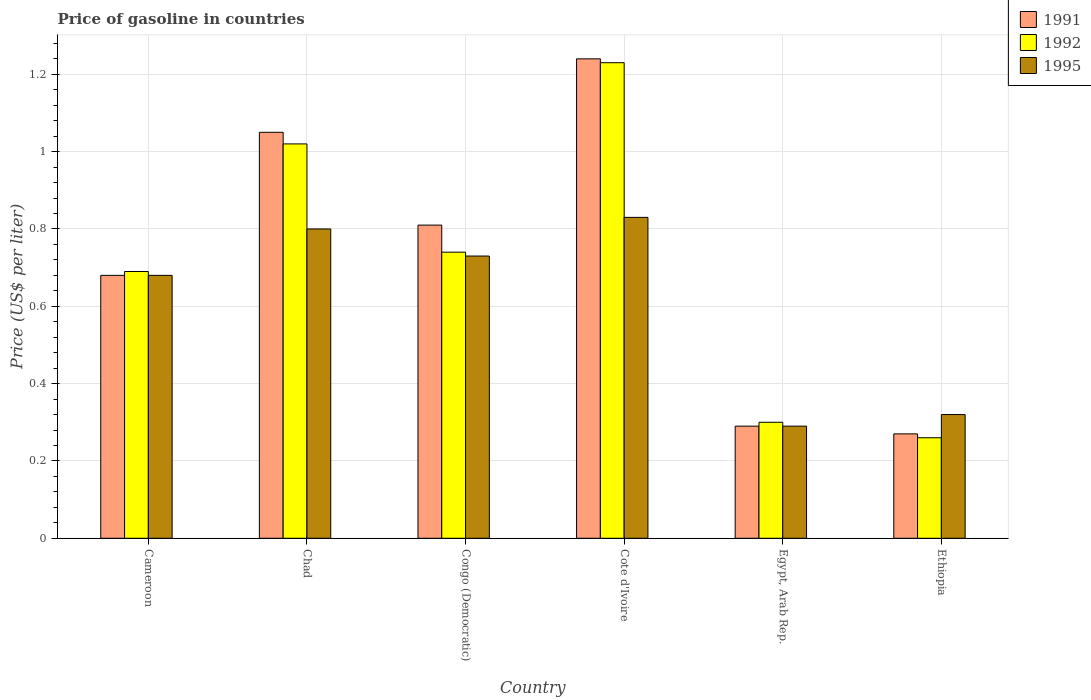How many groups of bars are there?
Offer a terse response. 6. Are the number of bars per tick equal to the number of legend labels?
Ensure brevity in your answer.  Yes. Are the number of bars on each tick of the X-axis equal?
Provide a succinct answer. Yes. What is the label of the 4th group of bars from the left?
Your answer should be compact. Cote d'Ivoire. What is the price of gasoline in 1995 in Cote d'Ivoire?
Provide a short and direct response. 0.83. Across all countries, what is the maximum price of gasoline in 1992?
Offer a terse response. 1.23. Across all countries, what is the minimum price of gasoline in 1992?
Provide a short and direct response. 0.26. In which country was the price of gasoline in 1991 maximum?
Offer a very short reply. Cote d'Ivoire. In which country was the price of gasoline in 1991 minimum?
Keep it short and to the point. Ethiopia. What is the total price of gasoline in 1992 in the graph?
Offer a terse response. 4.24. What is the difference between the price of gasoline in 1992 in Congo (Democratic) and that in Ethiopia?
Provide a short and direct response. 0.48. What is the difference between the price of gasoline in 1995 in Congo (Democratic) and the price of gasoline in 1992 in Ethiopia?
Give a very brief answer. 0.47. What is the average price of gasoline in 1991 per country?
Your answer should be compact. 0.72. What is the difference between the price of gasoline of/in 1995 and price of gasoline of/in 1991 in Cote d'Ivoire?
Your answer should be compact. -0.41. In how many countries, is the price of gasoline in 1995 greater than 0.9600000000000001 US$?
Offer a very short reply. 0. What is the ratio of the price of gasoline in 1992 in Chad to that in Cote d'Ivoire?
Offer a very short reply. 0.83. Is the difference between the price of gasoline in 1995 in Cameroon and Congo (Democratic) greater than the difference between the price of gasoline in 1991 in Cameroon and Congo (Democratic)?
Give a very brief answer. Yes. What is the difference between the highest and the second highest price of gasoline in 1991?
Make the answer very short. -0.43. What is the difference between the highest and the lowest price of gasoline in 1991?
Your answer should be very brief. 0.97. What does the 2nd bar from the left in Ethiopia represents?
Make the answer very short. 1992. What does the 2nd bar from the right in Chad represents?
Offer a terse response. 1992. Does the graph contain grids?
Ensure brevity in your answer.  Yes. Where does the legend appear in the graph?
Give a very brief answer. Top right. What is the title of the graph?
Your answer should be very brief. Price of gasoline in countries. Does "1996" appear as one of the legend labels in the graph?
Your response must be concise. No. What is the label or title of the Y-axis?
Keep it short and to the point. Price (US$ per liter). What is the Price (US$ per liter) of 1991 in Cameroon?
Keep it short and to the point. 0.68. What is the Price (US$ per liter) in 1992 in Cameroon?
Provide a succinct answer. 0.69. What is the Price (US$ per liter) of 1995 in Cameroon?
Provide a short and direct response. 0.68. What is the Price (US$ per liter) of 1991 in Chad?
Ensure brevity in your answer.  1.05. What is the Price (US$ per liter) of 1995 in Chad?
Provide a succinct answer. 0.8. What is the Price (US$ per liter) in 1991 in Congo (Democratic)?
Offer a terse response. 0.81. What is the Price (US$ per liter) in 1992 in Congo (Democratic)?
Ensure brevity in your answer.  0.74. What is the Price (US$ per liter) in 1995 in Congo (Democratic)?
Give a very brief answer. 0.73. What is the Price (US$ per liter) of 1991 in Cote d'Ivoire?
Give a very brief answer. 1.24. What is the Price (US$ per liter) of 1992 in Cote d'Ivoire?
Offer a very short reply. 1.23. What is the Price (US$ per liter) of 1995 in Cote d'Ivoire?
Keep it short and to the point. 0.83. What is the Price (US$ per liter) of 1991 in Egypt, Arab Rep.?
Give a very brief answer. 0.29. What is the Price (US$ per liter) in 1992 in Egypt, Arab Rep.?
Your response must be concise. 0.3. What is the Price (US$ per liter) of 1995 in Egypt, Arab Rep.?
Give a very brief answer. 0.29. What is the Price (US$ per liter) of 1991 in Ethiopia?
Provide a short and direct response. 0.27. What is the Price (US$ per liter) in 1992 in Ethiopia?
Your answer should be compact. 0.26. What is the Price (US$ per liter) in 1995 in Ethiopia?
Ensure brevity in your answer.  0.32. Across all countries, what is the maximum Price (US$ per liter) of 1991?
Keep it short and to the point. 1.24. Across all countries, what is the maximum Price (US$ per liter) of 1992?
Your response must be concise. 1.23. Across all countries, what is the maximum Price (US$ per liter) in 1995?
Ensure brevity in your answer.  0.83. Across all countries, what is the minimum Price (US$ per liter) in 1991?
Your answer should be very brief. 0.27. Across all countries, what is the minimum Price (US$ per liter) of 1992?
Keep it short and to the point. 0.26. Across all countries, what is the minimum Price (US$ per liter) in 1995?
Make the answer very short. 0.29. What is the total Price (US$ per liter) in 1991 in the graph?
Keep it short and to the point. 4.34. What is the total Price (US$ per liter) in 1992 in the graph?
Keep it short and to the point. 4.24. What is the total Price (US$ per liter) of 1995 in the graph?
Make the answer very short. 3.65. What is the difference between the Price (US$ per liter) of 1991 in Cameroon and that in Chad?
Keep it short and to the point. -0.37. What is the difference between the Price (US$ per liter) in 1992 in Cameroon and that in Chad?
Your answer should be very brief. -0.33. What is the difference between the Price (US$ per liter) of 1995 in Cameroon and that in Chad?
Give a very brief answer. -0.12. What is the difference between the Price (US$ per liter) in 1991 in Cameroon and that in Congo (Democratic)?
Offer a very short reply. -0.13. What is the difference between the Price (US$ per liter) in 1992 in Cameroon and that in Congo (Democratic)?
Your answer should be compact. -0.05. What is the difference between the Price (US$ per liter) of 1995 in Cameroon and that in Congo (Democratic)?
Give a very brief answer. -0.05. What is the difference between the Price (US$ per liter) in 1991 in Cameroon and that in Cote d'Ivoire?
Offer a very short reply. -0.56. What is the difference between the Price (US$ per liter) of 1992 in Cameroon and that in Cote d'Ivoire?
Provide a succinct answer. -0.54. What is the difference between the Price (US$ per liter) of 1995 in Cameroon and that in Cote d'Ivoire?
Provide a short and direct response. -0.15. What is the difference between the Price (US$ per liter) in 1991 in Cameroon and that in Egypt, Arab Rep.?
Offer a terse response. 0.39. What is the difference between the Price (US$ per liter) of 1992 in Cameroon and that in Egypt, Arab Rep.?
Ensure brevity in your answer.  0.39. What is the difference between the Price (US$ per liter) in 1995 in Cameroon and that in Egypt, Arab Rep.?
Provide a succinct answer. 0.39. What is the difference between the Price (US$ per liter) of 1991 in Cameroon and that in Ethiopia?
Your answer should be very brief. 0.41. What is the difference between the Price (US$ per liter) of 1992 in Cameroon and that in Ethiopia?
Make the answer very short. 0.43. What is the difference between the Price (US$ per liter) in 1995 in Cameroon and that in Ethiopia?
Your answer should be very brief. 0.36. What is the difference between the Price (US$ per liter) of 1991 in Chad and that in Congo (Democratic)?
Make the answer very short. 0.24. What is the difference between the Price (US$ per liter) of 1992 in Chad and that in Congo (Democratic)?
Ensure brevity in your answer.  0.28. What is the difference between the Price (US$ per liter) in 1995 in Chad and that in Congo (Democratic)?
Your response must be concise. 0.07. What is the difference between the Price (US$ per liter) in 1991 in Chad and that in Cote d'Ivoire?
Offer a very short reply. -0.19. What is the difference between the Price (US$ per liter) in 1992 in Chad and that in Cote d'Ivoire?
Your response must be concise. -0.21. What is the difference between the Price (US$ per liter) in 1995 in Chad and that in Cote d'Ivoire?
Provide a short and direct response. -0.03. What is the difference between the Price (US$ per liter) of 1991 in Chad and that in Egypt, Arab Rep.?
Offer a very short reply. 0.76. What is the difference between the Price (US$ per liter) of 1992 in Chad and that in Egypt, Arab Rep.?
Your response must be concise. 0.72. What is the difference between the Price (US$ per liter) of 1995 in Chad and that in Egypt, Arab Rep.?
Make the answer very short. 0.51. What is the difference between the Price (US$ per liter) in 1991 in Chad and that in Ethiopia?
Ensure brevity in your answer.  0.78. What is the difference between the Price (US$ per liter) in 1992 in Chad and that in Ethiopia?
Your answer should be very brief. 0.76. What is the difference between the Price (US$ per liter) of 1995 in Chad and that in Ethiopia?
Offer a terse response. 0.48. What is the difference between the Price (US$ per liter) in 1991 in Congo (Democratic) and that in Cote d'Ivoire?
Offer a very short reply. -0.43. What is the difference between the Price (US$ per liter) of 1992 in Congo (Democratic) and that in Cote d'Ivoire?
Offer a very short reply. -0.49. What is the difference between the Price (US$ per liter) in 1991 in Congo (Democratic) and that in Egypt, Arab Rep.?
Keep it short and to the point. 0.52. What is the difference between the Price (US$ per liter) of 1992 in Congo (Democratic) and that in Egypt, Arab Rep.?
Keep it short and to the point. 0.44. What is the difference between the Price (US$ per liter) in 1995 in Congo (Democratic) and that in Egypt, Arab Rep.?
Provide a succinct answer. 0.44. What is the difference between the Price (US$ per liter) in 1991 in Congo (Democratic) and that in Ethiopia?
Your response must be concise. 0.54. What is the difference between the Price (US$ per liter) of 1992 in Congo (Democratic) and that in Ethiopia?
Offer a terse response. 0.48. What is the difference between the Price (US$ per liter) of 1995 in Congo (Democratic) and that in Ethiopia?
Your answer should be very brief. 0.41. What is the difference between the Price (US$ per liter) of 1992 in Cote d'Ivoire and that in Egypt, Arab Rep.?
Your answer should be compact. 0.93. What is the difference between the Price (US$ per liter) of 1995 in Cote d'Ivoire and that in Egypt, Arab Rep.?
Offer a very short reply. 0.54. What is the difference between the Price (US$ per liter) of 1991 in Cote d'Ivoire and that in Ethiopia?
Provide a short and direct response. 0.97. What is the difference between the Price (US$ per liter) in 1995 in Cote d'Ivoire and that in Ethiopia?
Offer a very short reply. 0.51. What is the difference between the Price (US$ per liter) in 1991 in Egypt, Arab Rep. and that in Ethiopia?
Make the answer very short. 0.02. What is the difference between the Price (US$ per liter) of 1992 in Egypt, Arab Rep. and that in Ethiopia?
Your answer should be compact. 0.04. What is the difference between the Price (US$ per liter) in 1995 in Egypt, Arab Rep. and that in Ethiopia?
Ensure brevity in your answer.  -0.03. What is the difference between the Price (US$ per liter) in 1991 in Cameroon and the Price (US$ per liter) in 1992 in Chad?
Keep it short and to the point. -0.34. What is the difference between the Price (US$ per liter) of 1991 in Cameroon and the Price (US$ per liter) of 1995 in Chad?
Ensure brevity in your answer.  -0.12. What is the difference between the Price (US$ per liter) in 1992 in Cameroon and the Price (US$ per liter) in 1995 in Chad?
Provide a succinct answer. -0.11. What is the difference between the Price (US$ per liter) of 1991 in Cameroon and the Price (US$ per liter) of 1992 in Congo (Democratic)?
Offer a terse response. -0.06. What is the difference between the Price (US$ per liter) in 1991 in Cameroon and the Price (US$ per liter) in 1995 in Congo (Democratic)?
Make the answer very short. -0.05. What is the difference between the Price (US$ per liter) in 1992 in Cameroon and the Price (US$ per liter) in 1995 in Congo (Democratic)?
Keep it short and to the point. -0.04. What is the difference between the Price (US$ per liter) of 1991 in Cameroon and the Price (US$ per liter) of 1992 in Cote d'Ivoire?
Your response must be concise. -0.55. What is the difference between the Price (US$ per liter) in 1992 in Cameroon and the Price (US$ per liter) in 1995 in Cote d'Ivoire?
Your answer should be very brief. -0.14. What is the difference between the Price (US$ per liter) of 1991 in Cameroon and the Price (US$ per liter) of 1992 in Egypt, Arab Rep.?
Keep it short and to the point. 0.38. What is the difference between the Price (US$ per liter) of 1991 in Cameroon and the Price (US$ per liter) of 1995 in Egypt, Arab Rep.?
Offer a terse response. 0.39. What is the difference between the Price (US$ per liter) in 1991 in Cameroon and the Price (US$ per liter) in 1992 in Ethiopia?
Keep it short and to the point. 0.42. What is the difference between the Price (US$ per liter) in 1991 in Cameroon and the Price (US$ per liter) in 1995 in Ethiopia?
Offer a very short reply. 0.36. What is the difference between the Price (US$ per liter) in 1992 in Cameroon and the Price (US$ per liter) in 1995 in Ethiopia?
Offer a terse response. 0.37. What is the difference between the Price (US$ per liter) in 1991 in Chad and the Price (US$ per liter) in 1992 in Congo (Democratic)?
Provide a succinct answer. 0.31. What is the difference between the Price (US$ per liter) of 1991 in Chad and the Price (US$ per liter) of 1995 in Congo (Democratic)?
Offer a very short reply. 0.32. What is the difference between the Price (US$ per liter) in 1992 in Chad and the Price (US$ per liter) in 1995 in Congo (Democratic)?
Offer a very short reply. 0.29. What is the difference between the Price (US$ per liter) in 1991 in Chad and the Price (US$ per liter) in 1992 in Cote d'Ivoire?
Your answer should be compact. -0.18. What is the difference between the Price (US$ per liter) of 1991 in Chad and the Price (US$ per liter) of 1995 in Cote d'Ivoire?
Keep it short and to the point. 0.22. What is the difference between the Price (US$ per liter) in 1992 in Chad and the Price (US$ per liter) in 1995 in Cote d'Ivoire?
Offer a terse response. 0.19. What is the difference between the Price (US$ per liter) in 1991 in Chad and the Price (US$ per liter) in 1992 in Egypt, Arab Rep.?
Offer a very short reply. 0.75. What is the difference between the Price (US$ per liter) of 1991 in Chad and the Price (US$ per liter) of 1995 in Egypt, Arab Rep.?
Ensure brevity in your answer.  0.76. What is the difference between the Price (US$ per liter) in 1992 in Chad and the Price (US$ per liter) in 1995 in Egypt, Arab Rep.?
Offer a very short reply. 0.73. What is the difference between the Price (US$ per liter) of 1991 in Chad and the Price (US$ per liter) of 1992 in Ethiopia?
Ensure brevity in your answer.  0.79. What is the difference between the Price (US$ per liter) in 1991 in Chad and the Price (US$ per liter) in 1995 in Ethiopia?
Offer a very short reply. 0.73. What is the difference between the Price (US$ per liter) of 1991 in Congo (Democratic) and the Price (US$ per liter) of 1992 in Cote d'Ivoire?
Ensure brevity in your answer.  -0.42. What is the difference between the Price (US$ per liter) of 1991 in Congo (Democratic) and the Price (US$ per liter) of 1995 in Cote d'Ivoire?
Provide a short and direct response. -0.02. What is the difference between the Price (US$ per liter) of 1992 in Congo (Democratic) and the Price (US$ per liter) of 1995 in Cote d'Ivoire?
Your response must be concise. -0.09. What is the difference between the Price (US$ per liter) in 1991 in Congo (Democratic) and the Price (US$ per liter) in 1992 in Egypt, Arab Rep.?
Keep it short and to the point. 0.51. What is the difference between the Price (US$ per liter) of 1991 in Congo (Democratic) and the Price (US$ per liter) of 1995 in Egypt, Arab Rep.?
Offer a terse response. 0.52. What is the difference between the Price (US$ per liter) in 1992 in Congo (Democratic) and the Price (US$ per liter) in 1995 in Egypt, Arab Rep.?
Give a very brief answer. 0.45. What is the difference between the Price (US$ per liter) of 1991 in Congo (Democratic) and the Price (US$ per liter) of 1992 in Ethiopia?
Provide a short and direct response. 0.55. What is the difference between the Price (US$ per liter) of 1991 in Congo (Democratic) and the Price (US$ per liter) of 1995 in Ethiopia?
Your answer should be very brief. 0.49. What is the difference between the Price (US$ per liter) in 1992 in Congo (Democratic) and the Price (US$ per liter) in 1995 in Ethiopia?
Provide a short and direct response. 0.42. What is the difference between the Price (US$ per liter) in 1991 in Cote d'Ivoire and the Price (US$ per liter) in 1992 in Egypt, Arab Rep.?
Your response must be concise. 0.94. What is the difference between the Price (US$ per liter) of 1991 in Cote d'Ivoire and the Price (US$ per liter) of 1992 in Ethiopia?
Your answer should be very brief. 0.98. What is the difference between the Price (US$ per liter) in 1991 in Cote d'Ivoire and the Price (US$ per liter) in 1995 in Ethiopia?
Keep it short and to the point. 0.92. What is the difference between the Price (US$ per liter) in 1992 in Cote d'Ivoire and the Price (US$ per liter) in 1995 in Ethiopia?
Give a very brief answer. 0.91. What is the difference between the Price (US$ per liter) of 1991 in Egypt, Arab Rep. and the Price (US$ per liter) of 1995 in Ethiopia?
Make the answer very short. -0.03. What is the difference between the Price (US$ per liter) in 1992 in Egypt, Arab Rep. and the Price (US$ per liter) in 1995 in Ethiopia?
Make the answer very short. -0.02. What is the average Price (US$ per liter) in 1991 per country?
Provide a short and direct response. 0.72. What is the average Price (US$ per liter) of 1992 per country?
Offer a terse response. 0.71. What is the average Price (US$ per liter) of 1995 per country?
Make the answer very short. 0.61. What is the difference between the Price (US$ per liter) in 1991 and Price (US$ per liter) in 1992 in Cameroon?
Give a very brief answer. -0.01. What is the difference between the Price (US$ per liter) in 1991 and Price (US$ per liter) in 1995 in Cameroon?
Offer a very short reply. 0. What is the difference between the Price (US$ per liter) in 1992 and Price (US$ per liter) in 1995 in Cameroon?
Your answer should be very brief. 0.01. What is the difference between the Price (US$ per liter) in 1991 and Price (US$ per liter) in 1995 in Chad?
Offer a terse response. 0.25. What is the difference between the Price (US$ per liter) in 1992 and Price (US$ per liter) in 1995 in Chad?
Make the answer very short. 0.22. What is the difference between the Price (US$ per liter) in 1991 and Price (US$ per liter) in 1992 in Congo (Democratic)?
Ensure brevity in your answer.  0.07. What is the difference between the Price (US$ per liter) of 1991 and Price (US$ per liter) of 1992 in Cote d'Ivoire?
Your answer should be very brief. 0.01. What is the difference between the Price (US$ per liter) in 1991 and Price (US$ per liter) in 1995 in Cote d'Ivoire?
Keep it short and to the point. 0.41. What is the difference between the Price (US$ per liter) in 1992 and Price (US$ per liter) in 1995 in Cote d'Ivoire?
Offer a terse response. 0.4. What is the difference between the Price (US$ per liter) of 1991 and Price (US$ per liter) of 1992 in Egypt, Arab Rep.?
Offer a terse response. -0.01. What is the difference between the Price (US$ per liter) in 1992 and Price (US$ per liter) in 1995 in Ethiopia?
Offer a terse response. -0.06. What is the ratio of the Price (US$ per liter) of 1991 in Cameroon to that in Chad?
Keep it short and to the point. 0.65. What is the ratio of the Price (US$ per liter) of 1992 in Cameroon to that in Chad?
Your response must be concise. 0.68. What is the ratio of the Price (US$ per liter) of 1991 in Cameroon to that in Congo (Democratic)?
Provide a succinct answer. 0.84. What is the ratio of the Price (US$ per liter) of 1992 in Cameroon to that in Congo (Democratic)?
Your answer should be very brief. 0.93. What is the ratio of the Price (US$ per liter) in 1995 in Cameroon to that in Congo (Democratic)?
Your answer should be compact. 0.93. What is the ratio of the Price (US$ per liter) of 1991 in Cameroon to that in Cote d'Ivoire?
Provide a short and direct response. 0.55. What is the ratio of the Price (US$ per liter) of 1992 in Cameroon to that in Cote d'Ivoire?
Provide a succinct answer. 0.56. What is the ratio of the Price (US$ per liter) of 1995 in Cameroon to that in Cote d'Ivoire?
Ensure brevity in your answer.  0.82. What is the ratio of the Price (US$ per liter) of 1991 in Cameroon to that in Egypt, Arab Rep.?
Provide a succinct answer. 2.34. What is the ratio of the Price (US$ per liter) of 1992 in Cameroon to that in Egypt, Arab Rep.?
Your answer should be compact. 2.3. What is the ratio of the Price (US$ per liter) in 1995 in Cameroon to that in Egypt, Arab Rep.?
Make the answer very short. 2.34. What is the ratio of the Price (US$ per liter) of 1991 in Cameroon to that in Ethiopia?
Offer a very short reply. 2.52. What is the ratio of the Price (US$ per liter) in 1992 in Cameroon to that in Ethiopia?
Your answer should be compact. 2.65. What is the ratio of the Price (US$ per liter) in 1995 in Cameroon to that in Ethiopia?
Your response must be concise. 2.12. What is the ratio of the Price (US$ per liter) of 1991 in Chad to that in Congo (Democratic)?
Provide a succinct answer. 1.3. What is the ratio of the Price (US$ per liter) of 1992 in Chad to that in Congo (Democratic)?
Your response must be concise. 1.38. What is the ratio of the Price (US$ per liter) in 1995 in Chad to that in Congo (Democratic)?
Give a very brief answer. 1.1. What is the ratio of the Price (US$ per liter) of 1991 in Chad to that in Cote d'Ivoire?
Provide a short and direct response. 0.85. What is the ratio of the Price (US$ per liter) of 1992 in Chad to that in Cote d'Ivoire?
Give a very brief answer. 0.83. What is the ratio of the Price (US$ per liter) in 1995 in Chad to that in Cote d'Ivoire?
Provide a succinct answer. 0.96. What is the ratio of the Price (US$ per liter) of 1991 in Chad to that in Egypt, Arab Rep.?
Offer a terse response. 3.62. What is the ratio of the Price (US$ per liter) of 1995 in Chad to that in Egypt, Arab Rep.?
Offer a very short reply. 2.76. What is the ratio of the Price (US$ per liter) in 1991 in Chad to that in Ethiopia?
Your answer should be very brief. 3.89. What is the ratio of the Price (US$ per liter) of 1992 in Chad to that in Ethiopia?
Give a very brief answer. 3.92. What is the ratio of the Price (US$ per liter) of 1991 in Congo (Democratic) to that in Cote d'Ivoire?
Your answer should be very brief. 0.65. What is the ratio of the Price (US$ per liter) of 1992 in Congo (Democratic) to that in Cote d'Ivoire?
Provide a succinct answer. 0.6. What is the ratio of the Price (US$ per liter) of 1995 in Congo (Democratic) to that in Cote d'Ivoire?
Provide a succinct answer. 0.88. What is the ratio of the Price (US$ per liter) of 1991 in Congo (Democratic) to that in Egypt, Arab Rep.?
Keep it short and to the point. 2.79. What is the ratio of the Price (US$ per liter) in 1992 in Congo (Democratic) to that in Egypt, Arab Rep.?
Your answer should be compact. 2.47. What is the ratio of the Price (US$ per liter) in 1995 in Congo (Democratic) to that in Egypt, Arab Rep.?
Provide a succinct answer. 2.52. What is the ratio of the Price (US$ per liter) in 1992 in Congo (Democratic) to that in Ethiopia?
Keep it short and to the point. 2.85. What is the ratio of the Price (US$ per liter) of 1995 in Congo (Democratic) to that in Ethiopia?
Offer a very short reply. 2.28. What is the ratio of the Price (US$ per liter) of 1991 in Cote d'Ivoire to that in Egypt, Arab Rep.?
Give a very brief answer. 4.28. What is the ratio of the Price (US$ per liter) of 1995 in Cote d'Ivoire to that in Egypt, Arab Rep.?
Give a very brief answer. 2.86. What is the ratio of the Price (US$ per liter) of 1991 in Cote d'Ivoire to that in Ethiopia?
Give a very brief answer. 4.59. What is the ratio of the Price (US$ per liter) in 1992 in Cote d'Ivoire to that in Ethiopia?
Your answer should be compact. 4.73. What is the ratio of the Price (US$ per liter) in 1995 in Cote d'Ivoire to that in Ethiopia?
Your answer should be compact. 2.59. What is the ratio of the Price (US$ per liter) of 1991 in Egypt, Arab Rep. to that in Ethiopia?
Offer a very short reply. 1.07. What is the ratio of the Price (US$ per liter) in 1992 in Egypt, Arab Rep. to that in Ethiopia?
Your response must be concise. 1.15. What is the ratio of the Price (US$ per liter) of 1995 in Egypt, Arab Rep. to that in Ethiopia?
Provide a succinct answer. 0.91. What is the difference between the highest and the second highest Price (US$ per liter) of 1991?
Make the answer very short. 0.19. What is the difference between the highest and the second highest Price (US$ per liter) in 1992?
Your response must be concise. 0.21. What is the difference between the highest and the lowest Price (US$ per liter) in 1992?
Your response must be concise. 0.97. What is the difference between the highest and the lowest Price (US$ per liter) of 1995?
Your response must be concise. 0.54. 